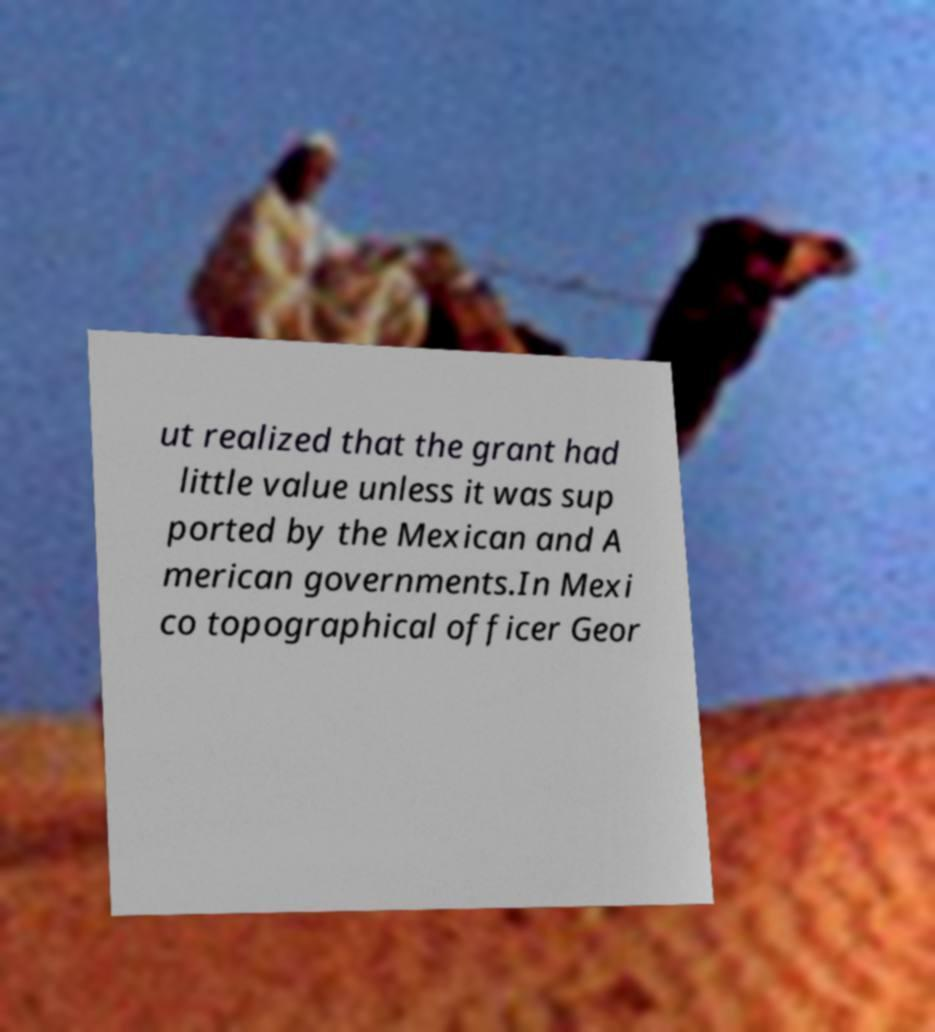I need the written content from this picture converted into text. Can you do that? ut realized that the grant had little value unless it was sup ported by the Mexican and A merican governments.In Mexi co topographical officer Geor 